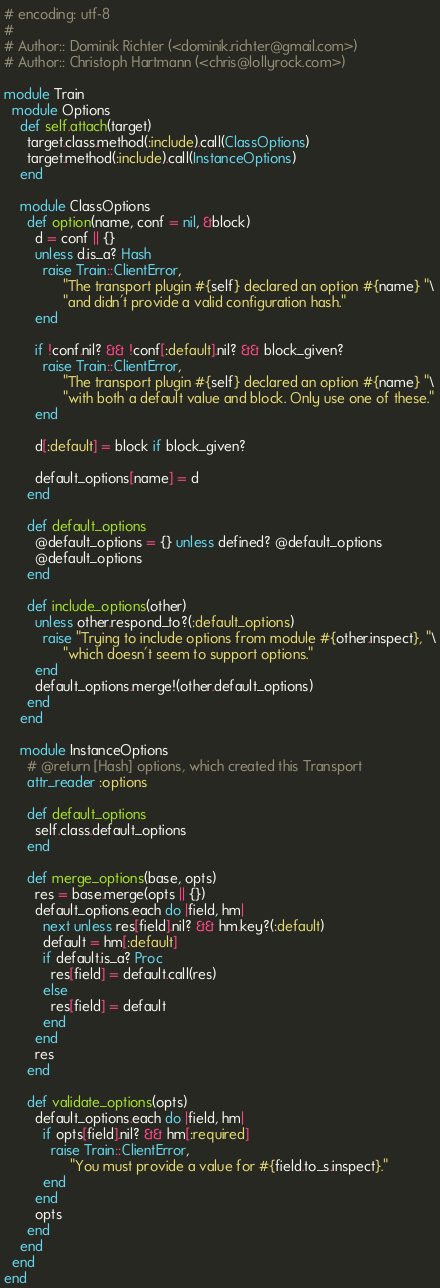Convert code to text. <code><loc_0><loc_0><loc_500><loc_500><_Ruby_># encoding: utf-8
#
# Author:: Dominik Richter (<dominik.richter@gmail.com>)
# Author:: Christoph Hartmann (<chris@lollyrock.com>)

module Train
  module Options
    def self.attach(target)
      target.class.method(:include).call(ClassOptions)
      target.method(:include).call(InstanceOptions)
    end

    module ClassOptions
      def option(name, conf = nil, &block)
        d = conf || {}
        unless d.is_a? Hash
          raise Train::ClientError,
               "The transport plugin #{self} declared an option #{name} "\
               "and didn't provide a valid configuration hash."
        end

        if !conf.nil? && !conf[:default].nil? && block_given?
          raise Train::ClientError,
               "The transport plugin #{self} declared an option #{name} "\
               "with both a default value and block. Only use one of these."
        end

        d[:default] = block if block_given?

        default_options[name] = d
      end

      def default_options
        @default_options = {} unless defined? @default_options
        @default_options
      end

      def include_options(other)
        unless other.respond_to?(:default_options)
          raise "Trying to include options from module #{other.inspect}, "\
               "which doesn't seem to support options."
        end
        default_options.merge!(other.default_options)
      end
    end

    module InstanceOptions
      # @return [Hash] options, which created this Transport
      attr_reader :options

      def default_options
        self.class.default_options
      end

      def merge_options(base, opts)
        res = base.merge(opts || {})
        default_options.each do |field, hm|
          next unless res[field].nil? && hm.key?(:default)
          default = hm[:default]
          if default.is_a? Proc
            res[field] = default.call(res)
          else
            res[field] = default
          end
        end
        res
      end

      def validate_options(opts)
        default_options.each do |field, hm|
          if opts[field].nil? && hm[:required]
            raise Train::ClientError,
                 "You must provide a value for #{field.to_s.inspect}."
          end
        end
        opts
      end
    end
  end
end
</code> 